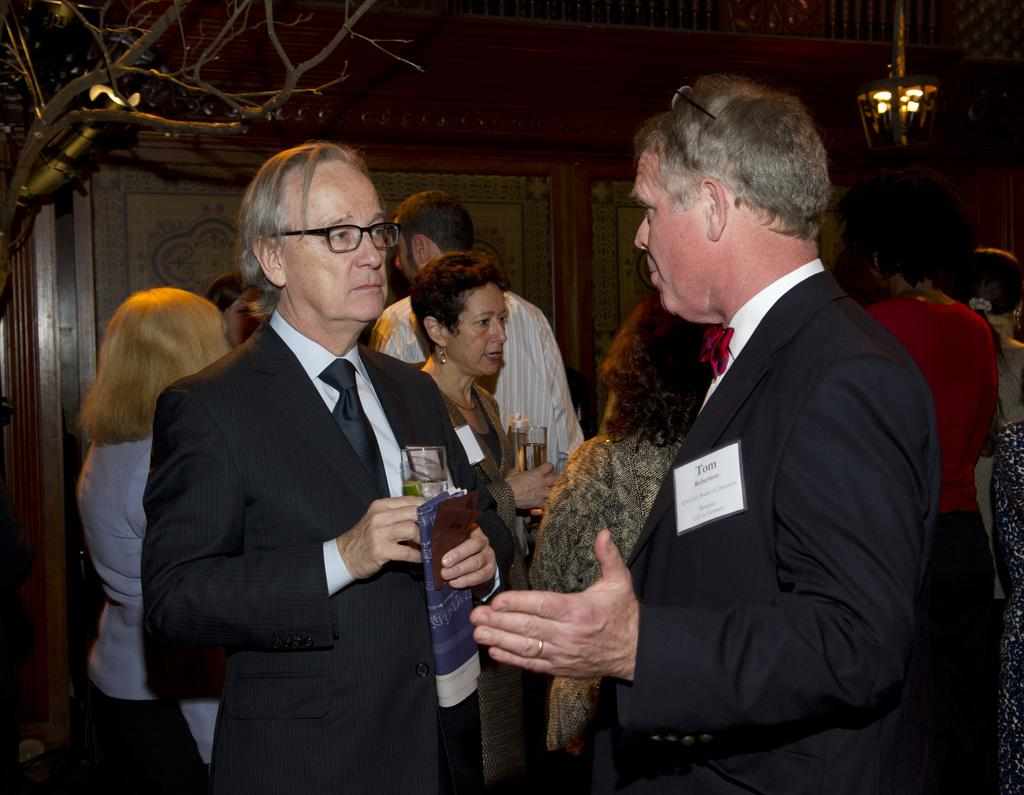What is happening in the image involving the group of people? The people in the image are standing and talking. Where is the scene taking place? The scene takes place in a room. What can be seen hanging from the ceiling in the room? There is a light hanging from the ceiling in the room. What type of cast is visible on the arm of one of the people in the image? There is no cast visible on any of the people in the image. Where can the shelf be found in the image? There is no shelf present in the image. 